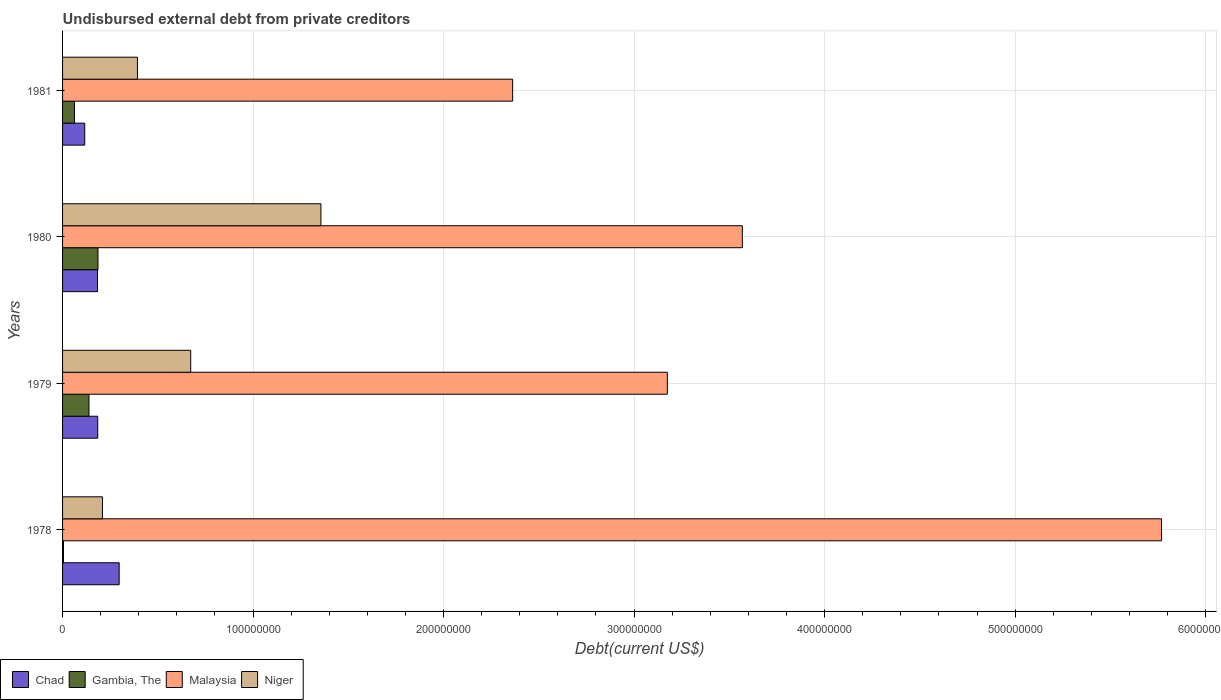How many groups of bars are there?
Provide a succinct answer. 4. Are the number of bars on each tick of the Y-axis equal?
Your response must be concise. Yes. How many bars are there on the 3rd tick from the top?
Your answer should be very brief. 4. What is the label of the 4th group of bars from the top?
Offer a terse response. 1978. In how many cases, is the number of bars for a given year not equal to the number of legend labels?
Offer a terse response. 0. What is the total debt in Malaysia in 1979?
Your answer should be compact. 3.17e+08. Across all years, what is the maximum total debt in Niger?
Offer a terse response. 1.36e+08. Across all years, what is the minimum total debt in Gambia, The?
Keep it short and to the point. 4.86e+05. In which year was the total debt in Gambia, The maximum?
Provide a succinct answer. 1980. In which year was the total debt in Gambia, The minimum?
Make the answer very short. 1978. What is the total total debt in Gambia, The in the graph?
Provide a succinct answer. 3.92e+07. What is the difference between the total debt in Malaysia in 1978 and that in 1979?
Give a very brief answer. 2.59e+08. What is the difference between the total debt in Chad in 1980 and the total debt in Niger in 1978?
Offer a very short reply. -2.60e+06. What is the average total debt in Niger per year?
Give a very brief answer. 6.58e+07. In the year 1979, what is the difference between the total debt in Niger and total debt in Malaysia?
Offer a terse response. -2.50e+08. In how many years, is the total debt in Niger greater than 240000000 US$?
Your answer should be compact. 0. What is the ratio of the total debt in Malaysia in 1979 to that in 1981?
Make the answer very short. 1.34. Is the total debt in Malaysia in 1979 less than that in 1980?
Provide a succinct answer. Yes. What is the difference between the highest and the second highest total debt in Niger?
Your answer should be compact. 6.83e+07. What is the difference between the highest and the lowest total debt in Malaysia?
Offer a terse response. 3.41e+08. In how many years, is the total debt in Malaysia greater than the average total debt in Malaysia taken over all years?
Your response must be concise. 1. Is the sum of the total debt in Gambia, The in 1980 and 1981 greater than the maximum total debt in Chad across all years?
Provide a succinct answer. No. Is it the case that in every year, the sum of the total debt in Malaysia and total debt in Gambia, The is greater than the sum of total debt in Chad and total debt in Niger?
Offer a very short reply. No. What does the 4th bar from the top in 1981 represents?
Your answer should be compact. Chad. What does the 3rd bar from the bottom in 1978 represents?
Your response must be concise. Malaysia. Are all the bars in the graph horizontal?
Make the answer very short. Yes. Are the values on the major ticks of X-axis written in scientific E-notation?
Keep it short and to the point. No. Does the graph contain any zero values?
Offer a very short reply. No. Does the graph contain grids?
Make the answer very short. Yes. Where does the legend appear in the graph?
Give a very brief answer. Bottom left. How many legend labels are there?
Offer a terse response. 4. How are the legend labels stacked?
Provide a short and direct response. Horizontal. What is the title of the graph?
Ensure brevity in your answer.  Undisbursed external debt from private creditors. What is the label or title of the X-axis?
Provide a succinct answer. Debt(current US$). What is the Debt(current US$) in Chad in 1978?
Provide a succinct answer. 2.97e+07. What is the Debt(current US$) in Gambia, The in 1978?
Offer a very short reply. 4.86e+05. What is the Debt(current US$) of Malaysia in 1978?
Keep it short and to the point. 5.77e+08. What is the Debt(current US$) of Niger in 1978?
Keep it short and to the point. 2.09e+07. What is the Debt(current US$) in Chad in 1979?
Your response must be concise. 1.85e+07. What is the Debt(current US$) in Gambia, The in 1979?
Make the answer very short. 1.39e+07. What is the Debt(current US$) in Malaysia in 1979?
Give a very brief answer. 3.17e+08. What is the Debt(current US$) in Niger in 1979?
Your answer should be very brief. 6.73e+07. What is the Debt(current US$) of Chad in 1980?
Give a very brief answer. 1.83e+07. What is the Debt(current US$) in Gambia, The in 1980?
Provide a succinct answer. 1.86e+07. What is the Debt(current US$) of Malaysia in 1980?
Give a very brief answer. 3.57e+08. What is the Debt(current US$) in Niger in 1980?
Ensure brevity in your answer.  1.36e+08. What is the Debt(current US$) in Chad in 1981?
Provide a short and direct response. 1.16e+07. What is the Debt(current US$) of Gambia, The in 1981?
Your answer should be very brief. 6.27e+06. What is the Debt(current US$) in Malaysia in 1981?
Your answer should be compact. 2.36e+08. What is the Debt(current US$) of Niger in 1981?
Offer a very short reply. 3.93e+07. Across all years, what is the maximum Debt(current US$) of Chad?
Keep it short and to the point. 2.97e+07. Across all years, what is the maximum Debt(current US$) of Gambia, The?
Offer a very short reply. 1.86e+07. Across all years, what is the maximum Debt(current US$) in Malaysia?
Offer a very short reply. 5.77e+08. Across all years, what is the maximum Debt(current US$) in Niger?
Ensure brevity in your answer.  1.36e+08. Across all years, what is the minimum Debt(current US$) in Chad?
Your answer should be compact. 1.16e+07. Across all years, what is the minimum Debt(current US$) in Gambia, The?
Offer a terse response. 4.86e+05. Across all years, what is the minimum Debt(current US$) of Malaysia?
Your answer should be compact. 2.36e+08. Across all years, what is the minimum Debt(current US$) in Niger?
Your answer should be very brief. 2.09e+07. What is the total Debt(current US$) of Chad in the graph?
Keep it short and to the point. 7.81e+07. What is the total Debt(current US$) of Gambia, The in the graph?
Your answer should be very brief. 3.92e+07. What is the total Debt(current US$) of Malaysia in the graph?
Make the answer very short. 1.49e+09. What is the total Debt(current US$) of Niger in the graph?
Offer a terse response. 2.63e+08. What is the difference between the Debt(current US$) of Chad in 1978 and that in 1979?
Your answer should be compact. 1.12e+07. What is the difference between the Debt(current US$) in Gambia, The in 1978 and that in 1979?
Your answer should be very brief. -1.34e+07. What is the difference between the Debt(current US$) of Malaysia in 1978 and that in 1979?
Offer a terse response. 2.59e+08. What is the difference between the Debt(current US$) in Niger in 1978 and that in 1979?
Ensure brevity in your answer.  -4.63e+07. What is the difference between the Debt(current US$) of Chad in 1978 and that in 1980?
Your answer should be compact. 1.14e+07. What is the difference between the Debt(current US$) of Gambia, The in 1978 and that in 1980?
Provide a short and direct response. -1.81e+07. What is the difference between the Debt(current US$) of Malaysia in 1978 and that in 1980?
Your answer should be very brief. 2.20e+08. What is the difference between the Debt(current US$) in Niger in 1978 and that in 1980?
Provide a succinct answer. -1.15e+08. What is the difference between the Debt(current US$) of Chad in 1978 and that in 1981?
Make the answer very short. 1.81e+07. What is the difference between the Debt(current US$) of Gambia, The in 1978 and that in 1981?
Make the answer very short. -5.78e+06. What is the difference between the Debt(current US$) in Malaysia in 1978 and that in 1981?
Give a very brief answer. 3.41e+08. What is the difference between the Debt(current US$) of Niger in 1978 and that in 1981?
Your response must be concise. -1.84e+07. What is the difference between the Debt(current US$) of Gambia, The in 1979 and that in 1980?
Your answer should be very brief. -4.72e+06. What is the difference between the Debt(current US$) of Malaysia in 1979 and that in 1980?
Provide a short and direct response. -3.94e+07. What is the difference between the Debt(current US$) in Niger in 1979 and that in 1980?
Make the answer very short. -6.83e+07. What is the difference between the Debt(current US$) in Chad in 1979 and that in 1981?
Your response must be concise. 6.82e+06. What is the difference between the Debt(current US$) in Gambia, The in 1979 and that in 1981?
Your response must be concise. 7.60e+06. What is the difference between the Debt(current US$) in Malaysia in 1979 and that in 1981?
Your response must be concise. 8.12e+07. What is the difference between the Debt(current US$) in Niger in 1979 and that in 1981?
Provide a short and direct response. 2.80e+07. What is the difference between the Debt(current US$) in Chad in 1980 and that in 1981?
Keep it short and to the point. 6.69e+06. What is the difference between the Debt(current US$) in Gambia, The in 1980 and that in 1981?
Provide a short and direct response. 1.23e+07. What is the difference between the Debt(current US$) of Malaysia in 1980 and that in 1981?
Give a very brief answer. 1.21e+08. What is the difference between the Debt(current US$) in Niger in 1980 and that in 1981?
Provide a short and direct response. 9.63e+07. What is the difference between the Debt(current US$) in Chad in 1978 and the Debt(current US$) in Gambia, The in 1979?
Your answer should be very brief. 1.58e+07. What is the difference between the Debt(current US$) of Chad in 1978 and the Debt(current US$) of Malaysia in 1979?
Provide a short and direct response. -2.88e+08. What is the difference between the Debt(current US$) in Chad in 1978 and the Debt(current US$) in Niger in 1979?
Your response must be concise. -3.76e+07. What is the difference between the Debt(current US$) of Gambia, The in 1978 and the Debt(current US$) of Malaysia in 1979?
Your answer should be very brief. -3.17e+08. What is the difference between the Debt(current US$) of Gambia, The in 1978 and the Debt(current US$) of Niger in 1979?
Offer a very short reply. -6.68e+07. What is the difference between the Debt(current US$) of Malaysia in 1978 and the Debt(current US$) of Niger in 1979?
Provide a succinct answer. 5.10e+08. What is the difference between the Debt(current US$) of Chad in 1978 and the Debt(current US$) of Gambia, The in 1980?
Your response must be concise. 1.11e+07. What is the difference between the Debt(current US$) in Chad in 1978 and the Debt(current US$) in Malaysia in 1980?
Your response must be concise. -3.27e+08. What is the difference between the Debt(current US$) in Chad in 1978 and the Debt(current US$) in Niger in 1980?
Provide a succinct answer. -1.06e+08. What is the difference between the Debt(current US$) of Gambia, The in 1978 and the Debt(current US$) of Malaysia in 1980?
Make the answer very short. -3.56e+08. What is the difference between the Debt(current US$) of Gambia, The in 1978 and the Debt(current US$) of Niger in 1980?
Keep it short and to the point. -1.35e+08. What is the difference between the Debt(current US$) in Malaysia in 1978 and the Debt(current US$) in Niger in 1980?
Provide a short and direct response. 4.41e+08. What is the difference between the Debt(current US$) of Chad in 1978 and the Debt(current US$) of Gambia, The in 1981?
Your answer should be very brief. 2.34e+07. What is the difference between the Debt(current US$) in Chad in 1978 and the Debt(current US$) in Malaysia in 1981?
Offer a terse response. -2.07e+08. What is the difference between the Debt(current US$) of Chad in 1978 and the Debt(current US$) of Niger in 1981?
Your answer should be compact. -9.60e+06. What is the difference between the Debt(current US$) in Gambia, The in 1978 and the Debt(current US$) in Malaysia in 1981?
Your answer should be compact. -2.36e+08. What is the difference between the Debt(current US$) in Gambia, The in 1978 and the Debt(current US$) in Niger in 1981?
Provide a short and direct response. -3.88e+07. What is the difference between the Debt(current US$) of Malaysia in 1978 and the Debt(current US$) of Niger in 1981?
Your answer should be very brief. 5.38e+08. What is the difference between the Debt(current US$) of Chad in 1979 and the Debt(current US$) of Gambia, The in 1980?
Your response must be concise. -1.25e+05. What is the difference between the Debt(current US$) of Chad in 1979 and the Debt(current US$) of Malaysia in 1980?
Your answer should be compact. -3.38e+08. What is the difference between the Debt(current US$) in Chad in 1979 and the Debt(current US$) in Niger in 1980?
Ensure brevity in your answer.  -1.17e+08. What is the difference between the Debt(current US$) of Gambia, The in 1979 and the Debt(current US$) of Malaysia in 1980?
Keep it short and to the point. -3.43e+08. What is the difference between the Debt(current US$) in Gambia, The in 1979 and the Debt(current US$) in Niger in 1980?
Provide a short and direct response. -1.22e+08. What is the difference between the Debt(current US$) in Malaysia in 1979 and the Debt(current US$) in Niger in 1980?
Offer a terse response. 1.82e+08. What is the difference between the Debt(current US$) in Chad in 1979 and the Debt(current US$) in Gambia, The in 1981?
Your response must be concise. 1.22e+07. What is the difference between the Debt(current US$) in Chad in 1979 and the Debt(current US$) in Malaysia in 1981?
Your response must be concise. -2.18e+08. What is the difference between the Debt(current US$) of Chad in 1979 and the Debt(current US$) of Niger in 1981?
Make the answer very short. -2.08e+07. What is the difference between the Debt(current US$) in Gambia, The in 1979 and the Debt(current US$) in Malaysia in 1981?
Offer a very short reply. -2.22e+08. What is the difference between the Debt(current US$) of Gambia, The in 1979 and the Debt(current US$) of Niger in 1981?
Make the answer very short. -2.54e+07. What is the difference between the Debt(current US$) in Malaysia in 1979 and the Debt(current US$) in Niger in 1981?
Keep it short and to the point. 2.78e+08. What is the difference between the Debt(current US$) of Chad in 1980 and the Debt(current US$) of Gambia, The in 1981?
Give a very brief answer. 1.21e+07. What is the difference between the Debt(current US$) in Chad in 1980 and the Debt(current US$) in Malaysia in 1981?
Keep it short and to the point. -2.18e+08. What is the difference between the Debt(current US$) of Chad in 1980 and the Debt(current US$) of Niger in 1981?
Provide a short and direct response. -2.10e+07. What is the difference between the Debt(current US$) in Gambia, The in 1980 and the Debt(current US$) in Malaysia in 1981?
Offer a very short reply. -2.18e+08. What is the difference between the Debt(current US$) in Gambia, The in 1980 and the Debt(current US$) in Niger in 1981?
Your response must be concise. -2.07e+07. What is the difference between the Debt(current US$) in Malaysia in 1980 and the Debt(current US$) in Niger in 1981?
Make the answer very short. 3.18e+08. What is the average Debt(current US$) of Chad per year?
Your answer should be very brief. 1.95e+07. What is the average Debt(current US$) of Gambia, The per year?
Your response must be concise. 9.80e+06. What is the average Debt(current US$) in Malaysia per year?
Give a very brief answer. 3.72e+08. What is the average Debt(current US$) in Niger per year?
Keep it short and to the point. 6.58e+07. In the year 1978, what is the difference between the Debt(current US$) in Chad and Debt(current US$) in Gambia, The?
Offer a terse response. 2.92e+07. In the year 1978, what is the difference between the Debt(current US$) in Chad and Debt(current US$) in Malaysia?
Your answer should be very brief. -5.47e+08. In the year 1978, what is the difference between the Debt(current US$) of Chad and Debt(current US$) of Niger?
Offer a very short reply. 8.78e+06. In the year 1978, what is the difference between the Debt(current US$) in Gambia, The and Debt(current US$) in Malaysia?
Offer a very short reply. -5.76e+08. In the year 1978, what is the difference between the Debt(current US$) in Gambia, The and Debt(current US$) in Niger?
Ensure brevity in your answer.  -2.04e+07. In the year 1978, what is the difference between the Debt(current US$) of Malaysia and Debt(current US$) of Niger?
Keep it short and to the point. 5.56e+08. In the year 1979, what is the difference between the Debt(current US$) in Chad and Debt(current US$) in Gambia, The?
Your answer should be very brief. 4.60e+06. In the year 1979, what is the difference between the Debt(current US$) in Chad and Debt(current US$) in Malaysia?
Your answer should be compact. -2.99e+08. In the year 1979, what is the difference between the Debt(current US$) in Chad and Debt(current US$) in Niger?
Make the answer very short. -4.88e+07. In the year 1979, what is the difference between the Debt(current US$) of Gambia, The and Debt(current US$) of Malaysia?
Keep it short and to the point. -3.04e+08. In the year 1979, what is the difference between the Debt(current US$) in Gambia, The and Debt(current US$) in Niger?
Make the answer very short. -5.34e+07. In the year 1979, what is the difference between the Debt(current US$) in Malaysia and Debt(current US$) in Niger?
Offer a very short reply. 2.50e+08. In the year 1980, what is the difference between the Debt(current US$) of Chad and Debt(current US$) of Gambia, The?
Provide a short and direct response. -2.55e+05. In the year 1980, what is the difference between the Debt(current US$) in Chad and Debt(current US$) in Malaysia?
Offer a very short reply. -3.38e+08. In the year 1980, what is the difference between the Debt(current US$) of Chad and Debt(current US$) of Niger?
Provide a short and direct response. -1.17e+08. In the year 1980, what is the difference between the Debt(current US$) in Gambia, The and Debt(current US$) in Malaysia?
Your response must be concise. -3.38e+08. In the year 1980, what is the difference between the Debt(current US$) in Gambia, The and Debt(current US$) in Niger?
Ensure brevity in your answer.  -1.17e+08. In the year 1980, what is the difference between the Debt(current US$) in Malaysia and Debt(current US$) in Niger?
Your answer should be compact. 2.21e+08. In the year 1981, what is the difference between the Debt(current US$) of Chad and Debt(current US$) of Gambia, The?
Give a very brief answer. 5.37e+06. In the year 1981, what is the difference between the Debt(current US$) of Chad and Debt(current US$) of Malaysia?
Make the answer very short. -2.25e+08. In the year 1981, what is the difference between the Debt(current US$) of Chad and Debt(current US$) of Niger?
Offer a terse response. -2.77e+07. In the year 1981, what is the difference between the Debt(current US$) of Gambia, The and Debt(current US$) of Malaysia?
Provide a succinct answer. -2.30e+08. In the year 1981, what is the difference between the Debt(current US$) in Gambia, The and Debt(current US$) in Niger?
Make the answer very short. -3.30e+07. In the year 1981, what is the difference between the Debt(current US$) of Malaysia and Debt(current US$) of Niger?
Provide a succinct answer. 1.97e+08. What is the ratio of the Debt(current US$) in Chad in 1978 to that in 1979?
Make the answer very short. 1.61. What is the ratio of the Debt(current US$) of Gambia, The in 1978 to that in 1979?
Provide a succinct answer. 0.04. What is the ratio of the Debt(current US$) in Malaysia in 1978 to that in 1979?
Make the answer very short. 1.82. What is the ratio of the Debt(current US$) in Niger in 1978 to that in 1979?
Offer a terse response. 0.31. What is the ratio of the Debt(current US$) of Chad in 1978 to that in 1980?
Offer a terse response. 1.62. What is the ratio of the Debt(current US$) in Gambia, The in 1978 to that in 1980?
Your answer should be compact. 0.03. What is the ratio of the Debt(current US$) of Malaysia in 1978 to that in 1980?
Make the answer very short. 1.62. What is the ratio of the Debt(current US$) of Niger in 1978 to that in 1980?
Offer a very short reply. 0.15. What is the ratio of the Debt(current US$) of Chad in 1978 to that in 1981?
Ensure brevity in your answer.  2.55. What is the ratio of the Debt(current US$) in Gambia, The in 1978 to that in 1981?
Your response must be concise. 0.08. What is the ratio of the Debt(current US$) in Malaysia in 1978 to that in 1981?
Offer a very short reply. 2.44. What is the ratio of the Debt(current US$) in Niger in 1978 to that in 1981?
Make the answer very short. 0.53. What is the ratio of the Debt(current US$) of Chad in 1979 to that in 1980?
Provide a succinct answer. 1.01. What is the ratio of the Debt(current US$) of Gambia, The in 1979 to that in 1980?
Offer a very short reply. 0.75. What is the ratio of the Debt(current US$) of Malaysia in 1979 to that in 1980?
Offer a terse response. 0.89. What is the ratio of the Debt(current US$) of Niger in 1979 to that in 1980?
Ensure brevity in your answer.  0.5. What is the ratio of the Debt(current US$) of Chad in 1979 to that in 1981?
Offer a terse response. 1.59. What is the ratio of the Debt(current US$) of Gambia, The in 1979 to that in 1981?
Make the answer very short. 2.21. What is the ratio of the Debt(current US$) of Malaysia in 1979 to that in 1981?
Give a very brief answer. 1.34. What is the ratio of the Debt(current US$) of Niger in 1979 to that in 1981?
Provide a short and direct response. 1.71. What is the ratio of the Debt(current US$) in Chad in 1980 to that in 1981?
Offer a very short reply. 1.58. What is the ratio of the Debt(current US$) of Gambia, The in 1980 to that in 1981?
Your answer should be very brief. 2.97. What is the ratio of the Debt(current US$) in Malaysia in 1980 to that in 1981?
Provide a short and direct response. 1.51. What is the ratio of the Debt(current US$) of Niger in 1980 to that in 1981?
Keep it short and to the point. 3.45. What is the difference between the highest and the second highest Debt(current US$) in Chad?
Provide a short and direct response. 1.12e+07. What is the difference between the highest and the second highest Debt(current US$) in Gambia, The?
Provide a short and direct response. 4.72e+06. What is the difference between the highest and the second highest Debt(current US$) in Malaysia?
Ensure brevity in your answer.  2.20e+08. What is the difference between the highest and the second highest Debt(current US$) in Niger?
Your answer should be compact. 6.83e+07. What is the difference between the highest and the lowest Debt(current US$) of Chad?
Your response must be concise. 1.81e+07. What is the difference between the highest and the lowest Debt(current US$) of Gambia, The?
Ensure brevity in your answer.  1.81e+07. What is the difference between the highest and the lowest Debt(current US$) in Malaysia?
Your answer should be compact. 3.41e+08. What is the difference between the highest and the lowest Debt(current US$) of Niger?
Make the answer very short. 1.15e+08. 